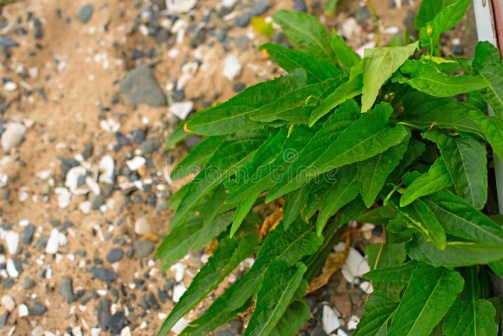What kind of ecosystem could this be a part of? This image likely represents an ecosystem characterized by rugged, rocky terrain, such as a mountainous or hillside environment. In such areas, plants with the resilience to grow in poor, rocky soil, like the one in the image, are common. These ecosystems are typically marked by a variety of hardy plants and shrubs that can withstand lower water availability and nutrient-poor conditions. Given the dirt pathway visible in the background, this might be an area frequented by humans, perhaps as part of a trail or a natural park. This type of ecosystem supports a range of flora and fauna adapted to more challenging growth conditions, providing an important ecological niche within a broader landscape. 